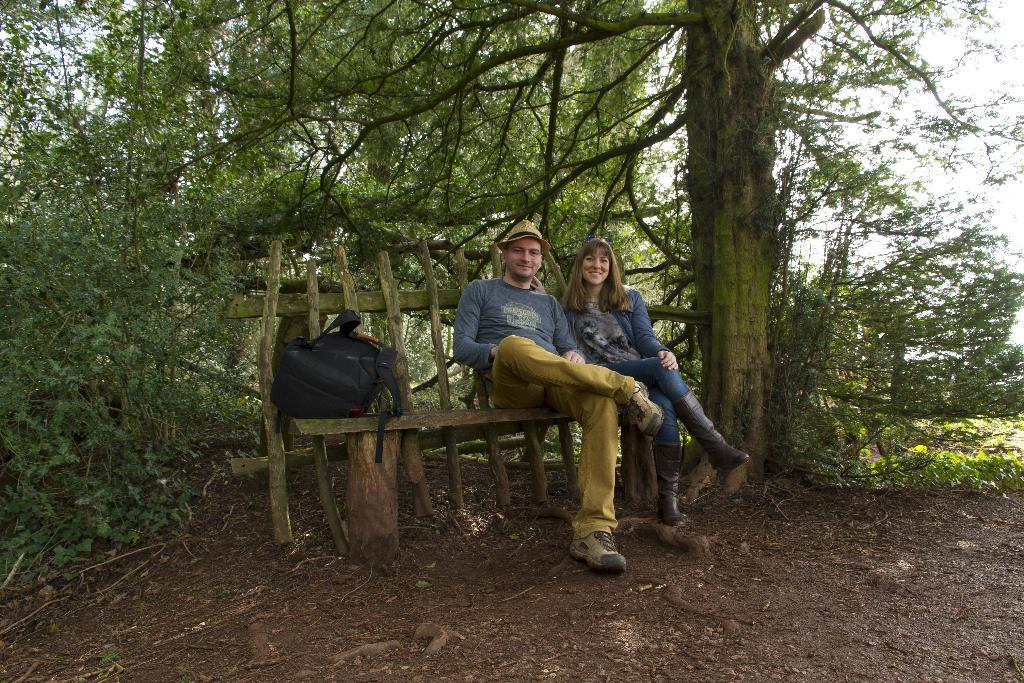Who can be seen in the image? There is a man and a woman in the image. What are they doing in the image? They are sitting on a bench. What object is beside them? There is a black color bag beside them. What can be seen in the background of the image? Trees are present in the background of the image. What type of quiver is the man holding in the image? There is no quiver present in the image; the man and woman are sitting on a bench with a black color bag beside them. 